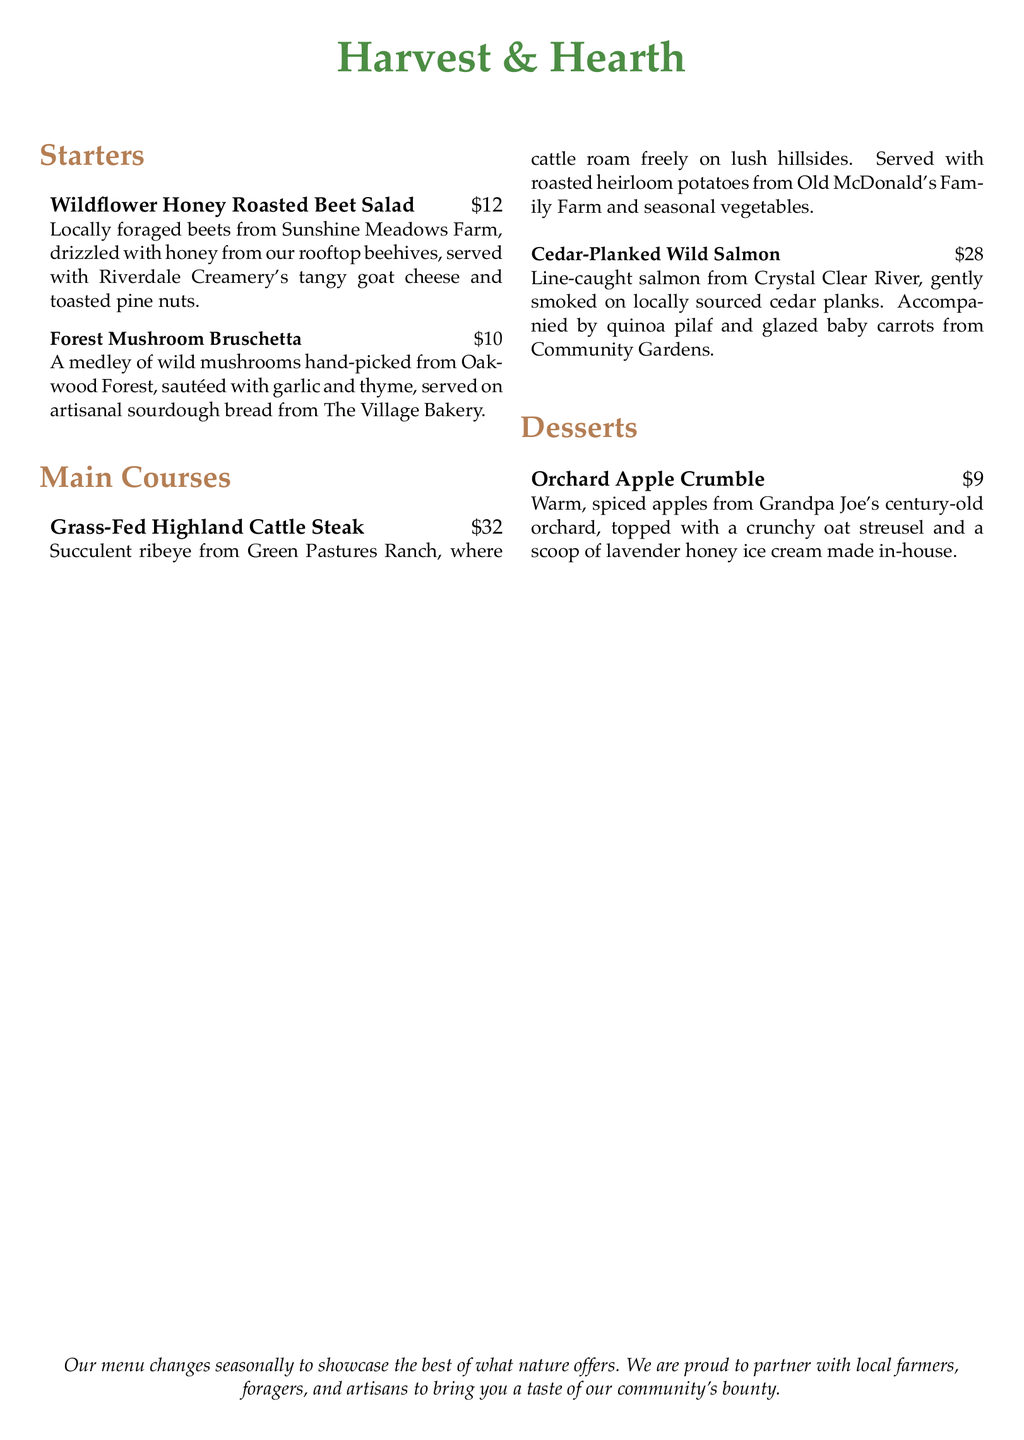What is the name of the restaurant? The name of the restaurant is prominently displayed at the top of the document.
Answer: Harvest & Hearth How much does the Wildflower Honey Roasted Beet Salad cost? The price of the Wildflower Honey Roasted Beet Salad is mentioned next to the dish.
Answer: $12 What farm do the beets in the salad come from? The origin of the beets is stated next to the dish description.
Answer: Sunshine Meadows Farm What type of cheese is served with the salad? The type of cheese accompanying the salad is explicitly mentioned in its description.
Answer: Goat cheese How is the Cedar-Planked Wild Salmon cooked? The preparation method for the Cedar-Planked Wild Salmon involves smoking it on cedar planks, as described in the document.
Answer: Smoked Which dish features apples from a century-old orchard? The dessert that highlights apples from a historic orchard is specifically detailed in the dessert section.
Answer: Orchard Apple Crumble List one vegetable that accompanies the Grass-Fed Highland Cattle Steak. The dish's description includes the mention of seasonal vegetables that accompany it.
Answer: Seasonal vegetables What is the source of honey used in the salad? The document specifies where the honey served with the salad is sourced from, which is relevant to the menu's theme.
Answer: Rooftop beehives What is the main theme of the menu? The menu includes a statement that reflects its core philosophy, indicating its overall focus.
Answer: Locally-sourced, sustainable ingredients 